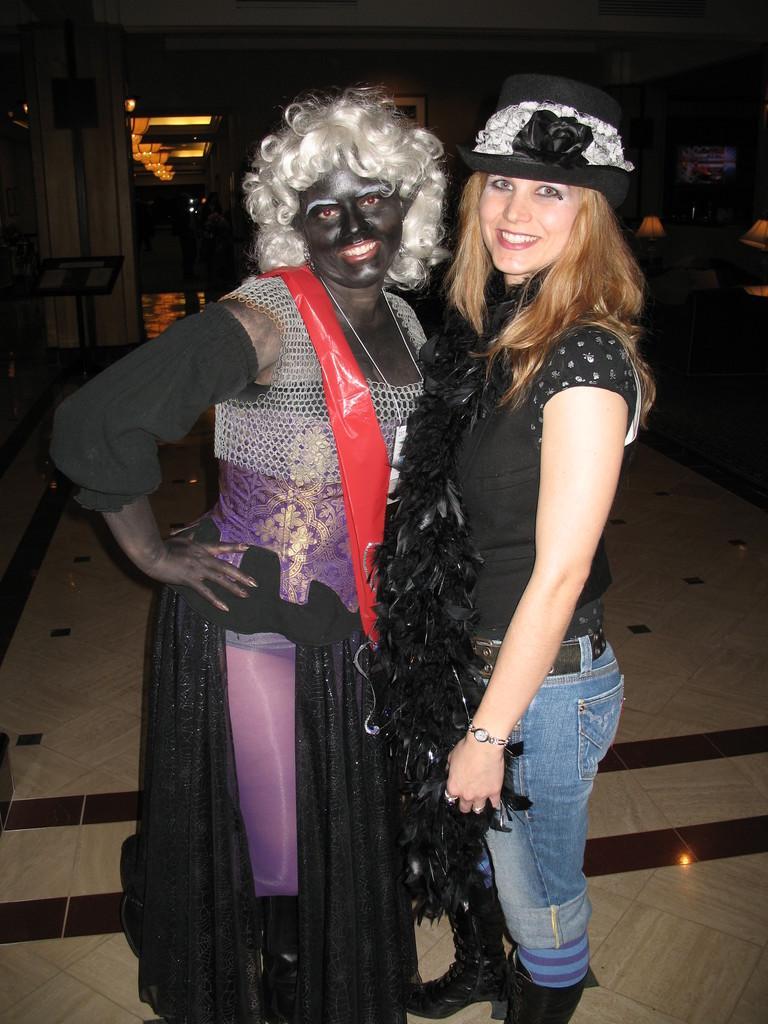Describe this image in one or two sentences. In this image, we can see a person wearing a costume and standing beside a woman in a hat. They both are smiling. At the bottom of the image, there is a floor. In the background, we can see the dark, lights, people, walls, showpieces and some objects.  